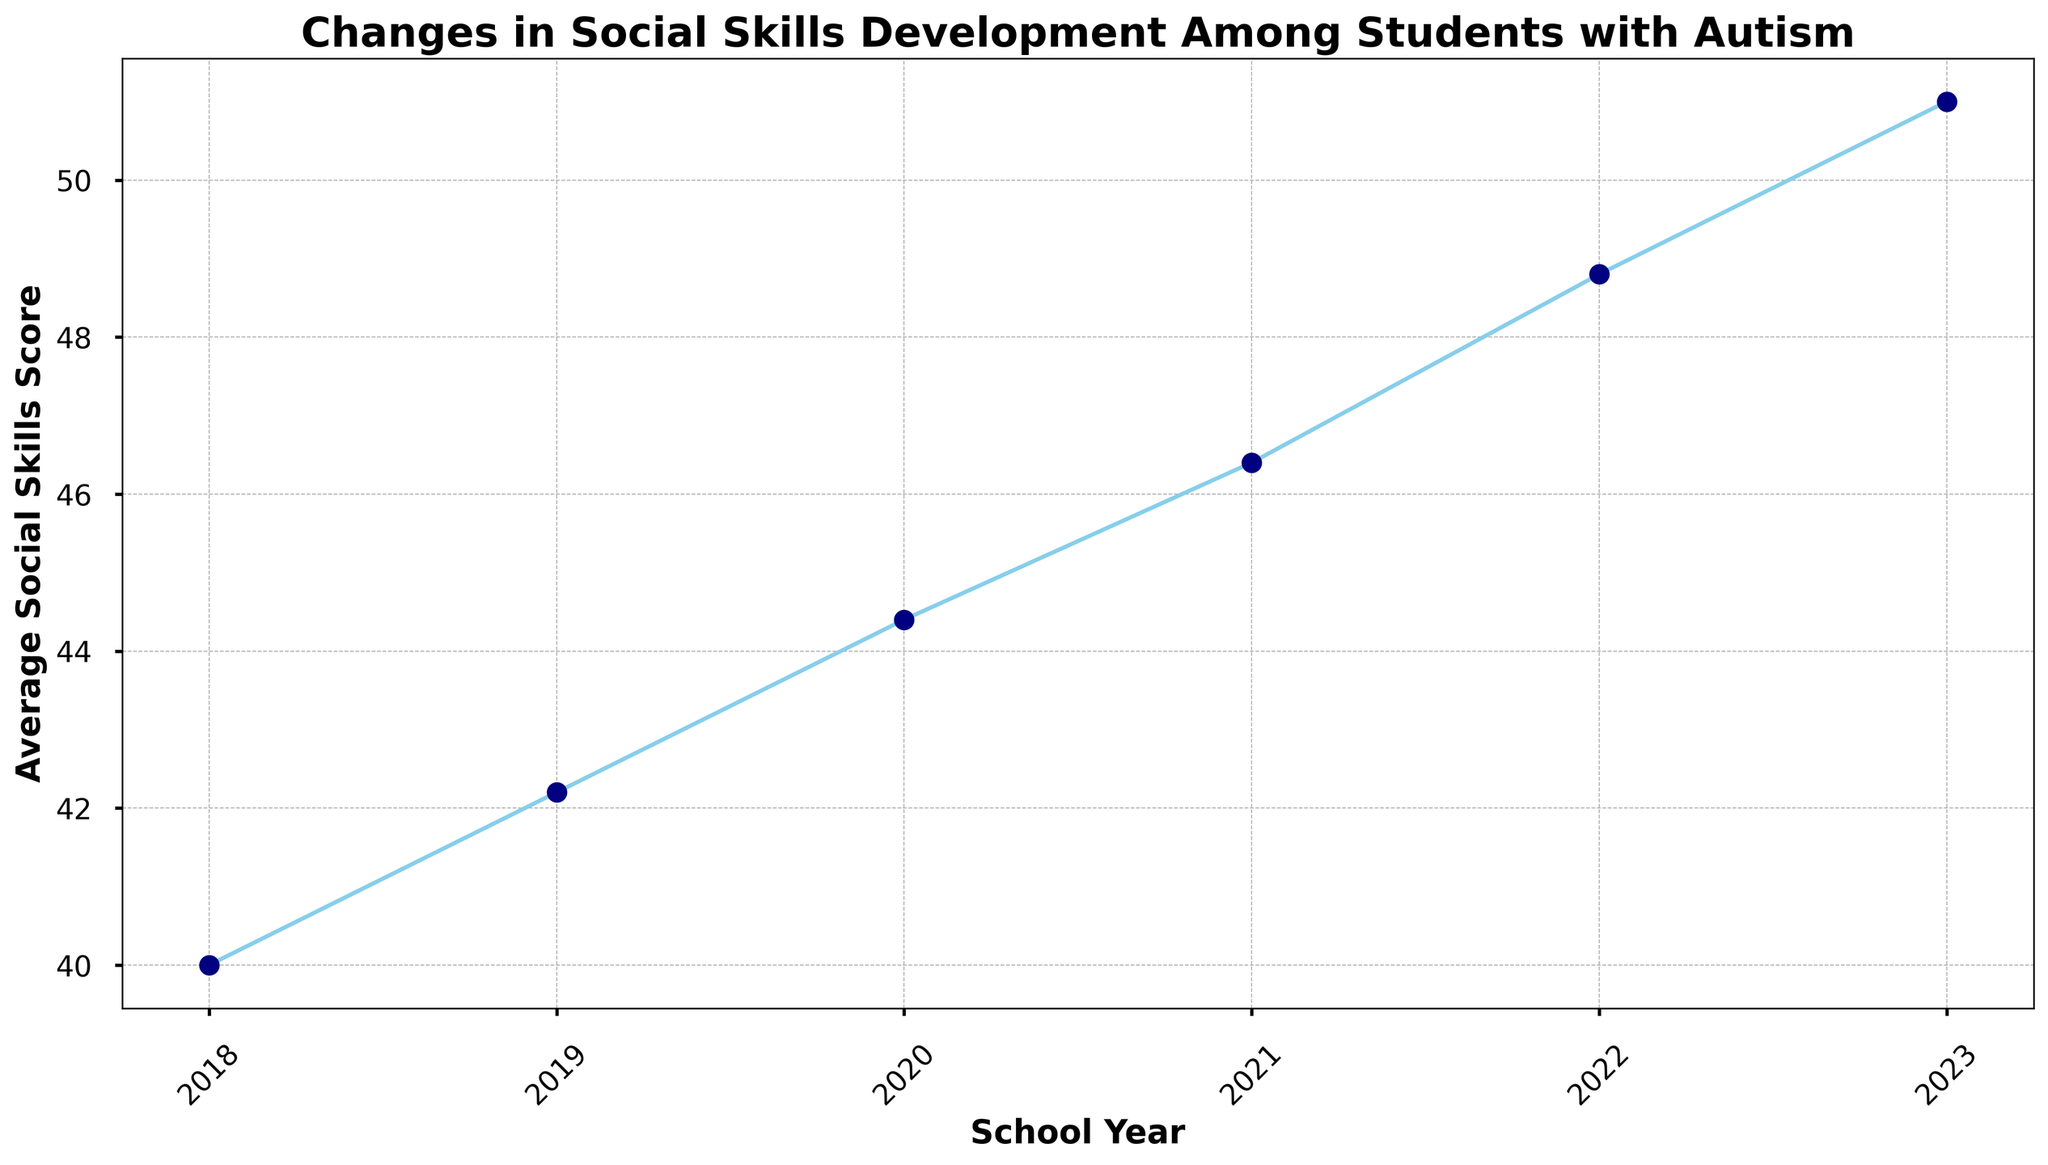What is the trend of average social skills scores from 2018 to 2023? Observe the general direction in which the line is moving. Over the years from 2018 to 2023, the average social skills scores show a consistent upward trend.
Answer: Upward trend What is the average social skills score for the year 2020? Locate the data point on the line corresponding to the year 2020 and note its value on the y-axis. The average social skills score for the year 2020 is around 44.
Answer: 44 Which year saw the highest average social skills score? Identify the highest point on the line chart and note the corresponding year on the x-axis. The highest average social skills score is observed in the year 2023.
Answer: 2023 How does the average social skills score in 2019 compare to that in 2022? Locate the data points for 2019 and 2022 on the line chart and compare their y-axis values. The average social skills score in 2022 is higher than in 2019.
Answer: 2022 is higher Calculate the increase in average social skills score from 2018 to 2023. Subtract the average social skills score in 2018 from the score in 2023. 50 (2023) - 40 (2018) = 10. So, the increase is 10.
Answer: 10 In which year did the average social skills score cross 50 for the first time? Determine the first data point on the line chart where the y-axis value exceeds 50. The score first crosses 50 in the year 2021.
Answer: 2021 What visual attributes indicate the data points on the line chart? Describe the visual aspects used to mark data points. Data points are indicated using sky blue circles with navy-colored centers on the line chart.
Answer: Sky blue circles with navy centers Compare the average social skills scores between the years 2020 and 2021. Locate the data points for 2020 and 2021 on the line chart and compare their y-axis values. The score in 2021 is higher than in 2020.
Answer: 2021 is higher What is the average increase in social skills scores per year from 2018 to 2023? Calculate the total increase from 2018 to 2023, then divide by the number of intervals (2023-2018 = 5 years). (50 - 40) / 5 = 2.
Answer: 2 Which two consecutive years show the smallest increase in average social skills score? Examine the gaps between consecutive data points and identify the smallest increase. The smallest increase is between 2018 and 2019, where the score increased by 1.
Answer: 2018 and 2019 